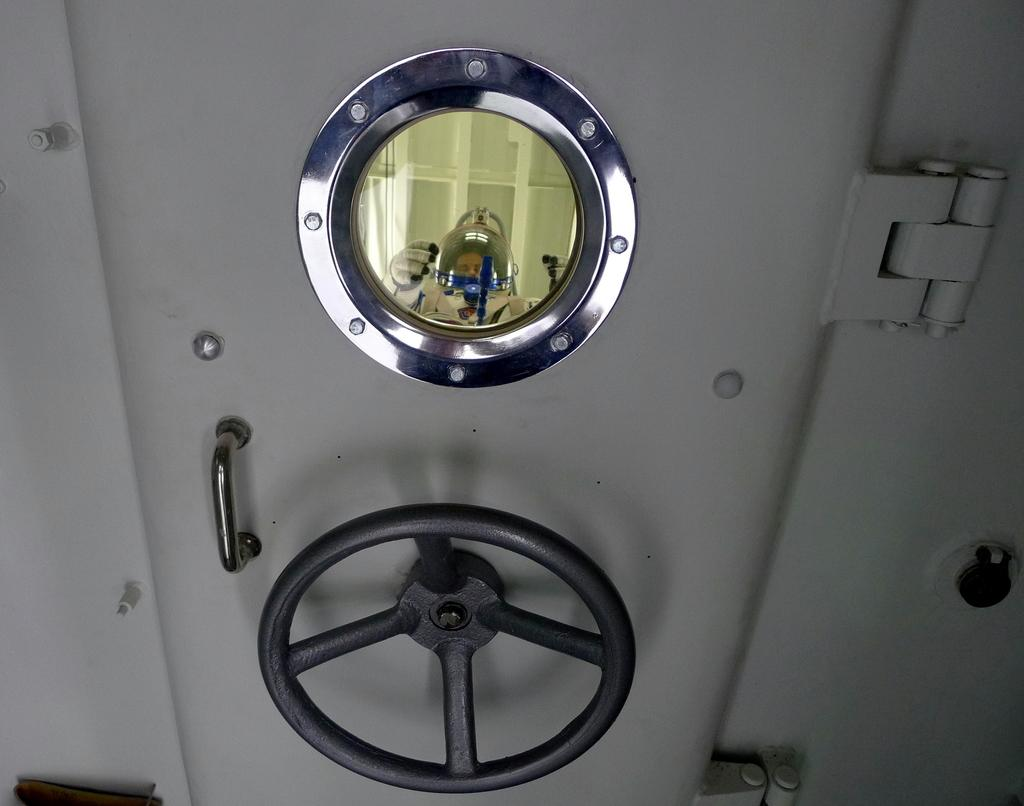What feature can be seen on the door in the image? A: There is a handle on the door in the image. Can you describe what is visible through the glass in the image? There is a person visible through the glass in the image. What type of seed is the writer planting in the notebook in the image? There is no seed, writer, or notebook present in the image. 